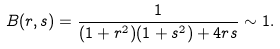Convert formula to latex. <formula><loc_0><loc_0><loc_500><loc_500>B ( r , s ) = \frac { 1 } { ( 1 + r ^ { 2 } ) ( 1 + s ^ { 2 } ) + 4 r s } \sim 1 .</formula> 